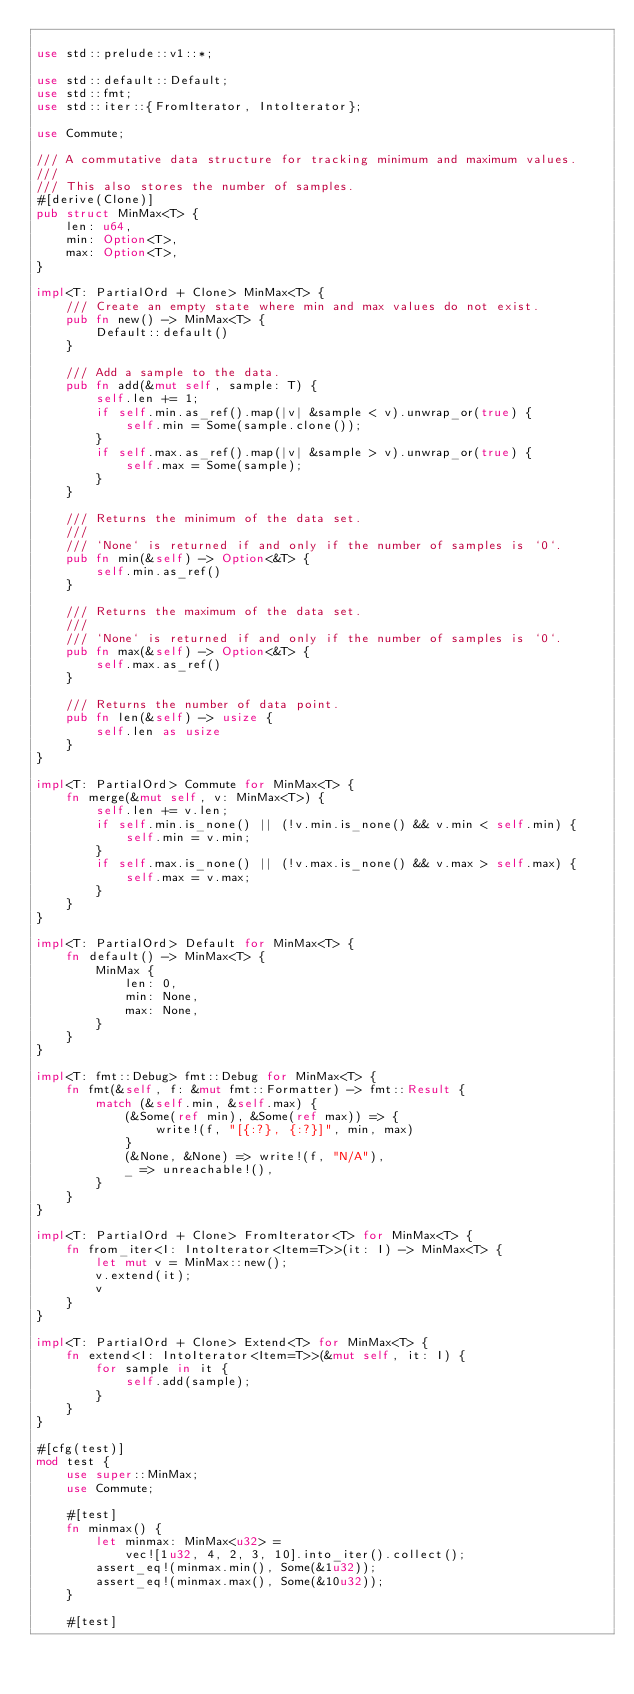Convert code to text. <code><loc_0><loc_0><loc_500><loc_500><_Rust_>
use std::prelude::v1::*;

use std::default::Default;
use std::fmt;
use std::iter::{FromIterator, IntoIterator};

use Commute;

/// A commutative data structure for tracking minimum and maximum values.
///
/// This also stores the number of samples.
#[derive(Clone)]
pub struct MinMax<T> {
    len: u64,
    min: Option<T>,
    max: Option<T>,
}

impl<T: PartialOrd + Clone> MinMax<T> {
    /// Create an empty state where min and max values do not exist.
    pub fn new() -> MinMax<T> {
        Default::default()
    }

    /// Add a sample to the data.
    pub fn add(&mut self, sample: T) {
        self.len += 1;
        if self.min.as_ref().map(|v| &sample < v).unwrap_or(true) {
            self.min = Some(sample.clone());
        }
        if self.max.as_ref().map(|v| &sample > v).unwrap_or(true) {
            self.max = Some(sample);
        }
    }

    /// Returns the minimum of the data set.
    ///
    /// `None` is returned if and only if the number of samples is `0`.
    pub fn min(&self) -> Option<&T> {
        self.min.as_ref()
    }

    /// Returns the maximum of the data set.
    ///
    /// `None` is returned if and only if the number of samples is `0`.
    pub fn max(&self) -> Option<&T> {
        self.max.as_ref()
    }

    /// Returns the number of data point.
    pub fn len(&self) -> usize {
        self.len as usize
    }
}

impl<T: PartialOrd> Commute for MinMax<T> {
    fn merge(&mut self, v: MinMax<T>) {
        self.len += v.len;
        if self.min.is_none() || (!v.min.is_none() && v.min < self.min) {
            self.min = v.min;
        }
        if self.max.is_none() || (!v.max.is_none() && v.max > self.max) {
            self.max = v.max;
        }
    }
}

impl<T: PartialOrd> Default for MinMax<T> {
    fn default() -> MinMax<T> {
        MinMax {
            len: 0,
            min: None,
            max: None,
        }
    }
}

impl<T: fmt::Debug> fmt::Debug for MinMax<T> {
    fn fmt(&self, f: &mut fmt::Formatter) -> fmt::Result {
        match (&self.min, &self.max) {
            (&Some(ref min), &Some(ref max)) => {
                write!(f, "[{:?}, {:?}]", min, max)
            }
            (&None, &None) => write!(f, "N/A"),
            _ => unreachable!(),
        }
    }
}

impl<T: PartialOrd + Clone> FromIterator<T> for MinMax<T> {
    fn from_iter<I: IntoIterator<Item=T>>(it: I) -> MinMax<T> {
        let mut v = MinMax::new();
        v.extend(it);
        v
    }
}

impl<T: PartialOrd + Clone> Extend<T> for MinMax<T> {
    fn extend<I: IntoIterator<Item=T>>(&mut self, it: I) {
        for sample in it {
            self.add(sample);
        }
    }
}

#[cfg(test)]
mod test {
    use super::MinMax;
    use Commute;

    #[test]
    fn minmax() {
        let minmax: MinMax<u32> =
            vec![1u32, 4, 2, 3, 10].into_iter().collect();
        assert_eq!(minmax.min(), Some(&1u32));
        assert_eq!(minmax.max(), Some(&10u32));
    }

    #[test]</code> 